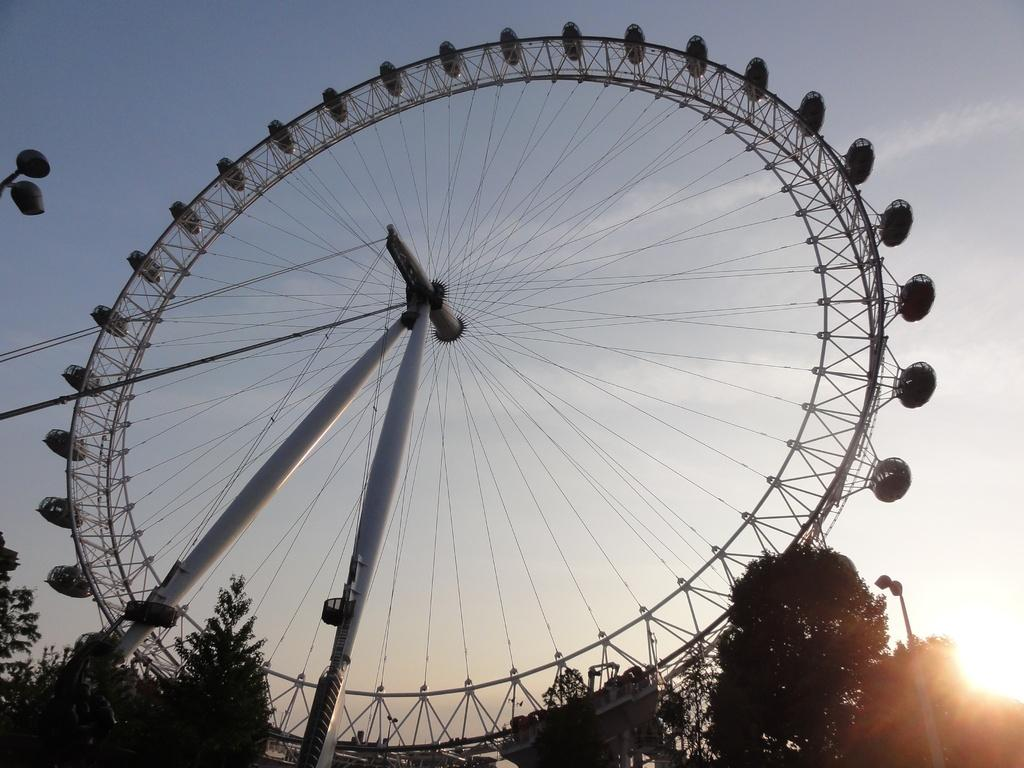What is located in the background of the image? There is a ferris wheel and trees in the background of the image. What else can be seen in the background of the image? The sky is visible in the background of the image. How many jellyfish are swimming in the sky in the image? There are no jellyfish present in the image; it features a ferris wheel, trees, and the sky. What type of horse can be seen grazing in the background of the image? There is no horse present in the image; it features a ferris wheel, trees, and the sky. 